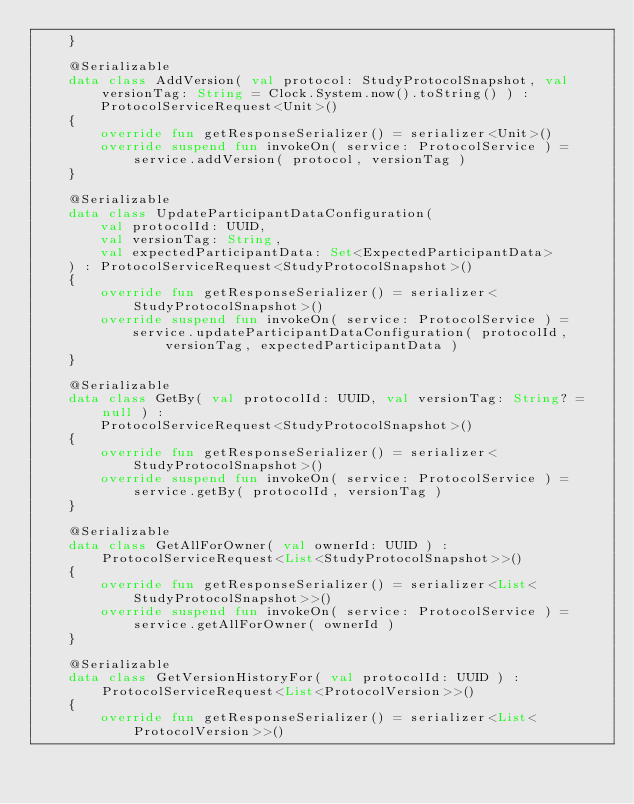<code> <loc_0><loc_0><loc_500><loc_500><_Kotlin_>    }

    @Serializable
    data class AddVersion( val protocol: StudyProtocolSnapshot, val versionTag: String = Clock.System.now().toString() ) :
        ProtocolServiceRequest<Unit>()
    {
        override fun getResponseSerializer() = serializer<Unit>()
        override suspend fun invokeOn( service: ProtocolService ) = service.addVersion( protocol, versionTag )
    }

    @Serializable
    data class UpdateParticipantDataConfiguration(
        val protocolId: UUID,
        val versionTag: String,
        val expectedParticipantData: Set<ExpectedParticipantData>
    ) : ProtocolServiceRequest<StudyProtocolSnapshot>()
    {
        override fun getResponseSerializer() = serializer<StudyProtocolSnapshot>()
        override suspend fun invokeOn( service: ProtocolService ) =
            service.updateParticipantDataConfiguration( protocolId, versionTag, expectedParticipantData )
    }

    @Serializable
    data class GetBy( val protocolId: UUID, val versionTag: String? = null ) :
        ProtocolServiceRequest<StudyProtocolSnapshot>()
    {
        override fun getResponseSerializer() = serializer<StudyProtocolSnapshot>()
        override suspend fun invokeOn( service: ProtocolService ) = service.getBy( protocolId, versionTag )
    }

    @Serializable
    data class GetAllForOwner( val ownerId: UUID ) : ProtocolServiceRequest<List<StudyProtocolSnapshot>>()
    {
        override fun getResponseSerializer() = serializer<List<StudyProtocolSnapshot>>()
        override suspend fun invokeOn( service: ProtocolService ) = service.getAllForOwner( ownerId )
    }

    @Serializable
    data class GetVersionHistoryFor( val protocolId: UUID ) : ProtocolServiceRequest<List<ProtocolVersion>>()
    {
        override fun getResponseSerializer() = serializer<List<ProtocolVersion>>()</code> 